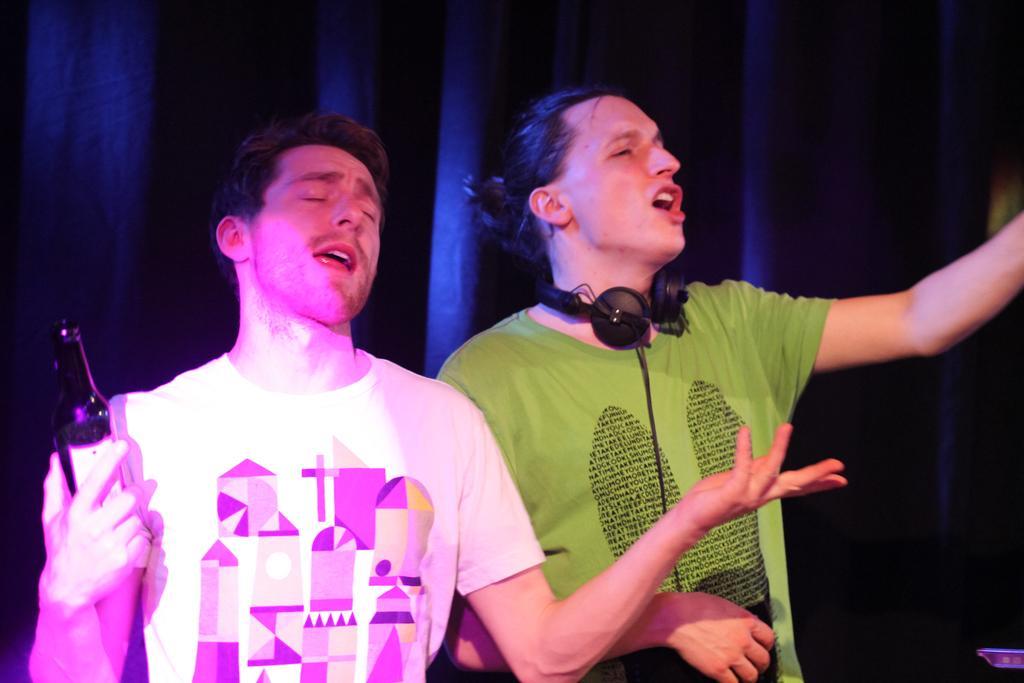Describe this image in one or two sentences. On the right there is a man he wear green t shirt , i think he is singing. On the left there is a man ,he wear white t shirt ,he hold a bottle in his hands ,he is singing. 